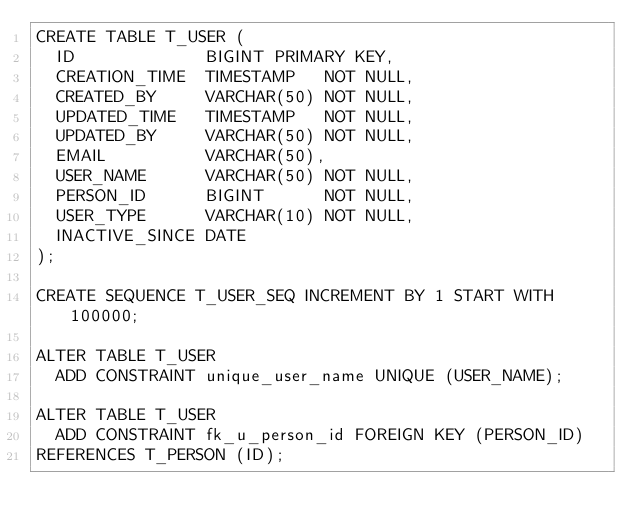Convert code to text. <code><loc_0><loc_0><loc_500><loc_500><_SQL_>CREATE TABLE T_USER (
  ID             BIGINT PRIMARY KEY,
  CREATION_TIME  TIMESTAMP   NOT NULL,
  CREATED_BY     VARCHAR(50) NOT NULL,
  UPDATED_TIME   TIMESTAMP   NOT NULL,
  UPDATED_BY     VARCHAR(50) NOT NULL,
  EMAIL          VARCHAR(50),
  USER_NAME      VARCHAR(50) NOT NULL,
  PERSON_ID      BIGINT      NOT NULL,
  USER_TYPE      VARCHAR(10) NOT NULL,
  INACTIVE_SINCE DATE
);

CREATE SEQUENCE T_USER_SEQ INCREMENT BY 1 START WITH 100000;

ALTER TABLE T_USER
  ADD CONSTRAINT unique_user_name UNIQUE (USER_NAME);

ALTER TABLE T_USER
  ADD CONSTRAINT fk_u_person_id FOREIGN KEY (PERSON_ID)
REFERENCES T_PERSON (ID);
</code> 